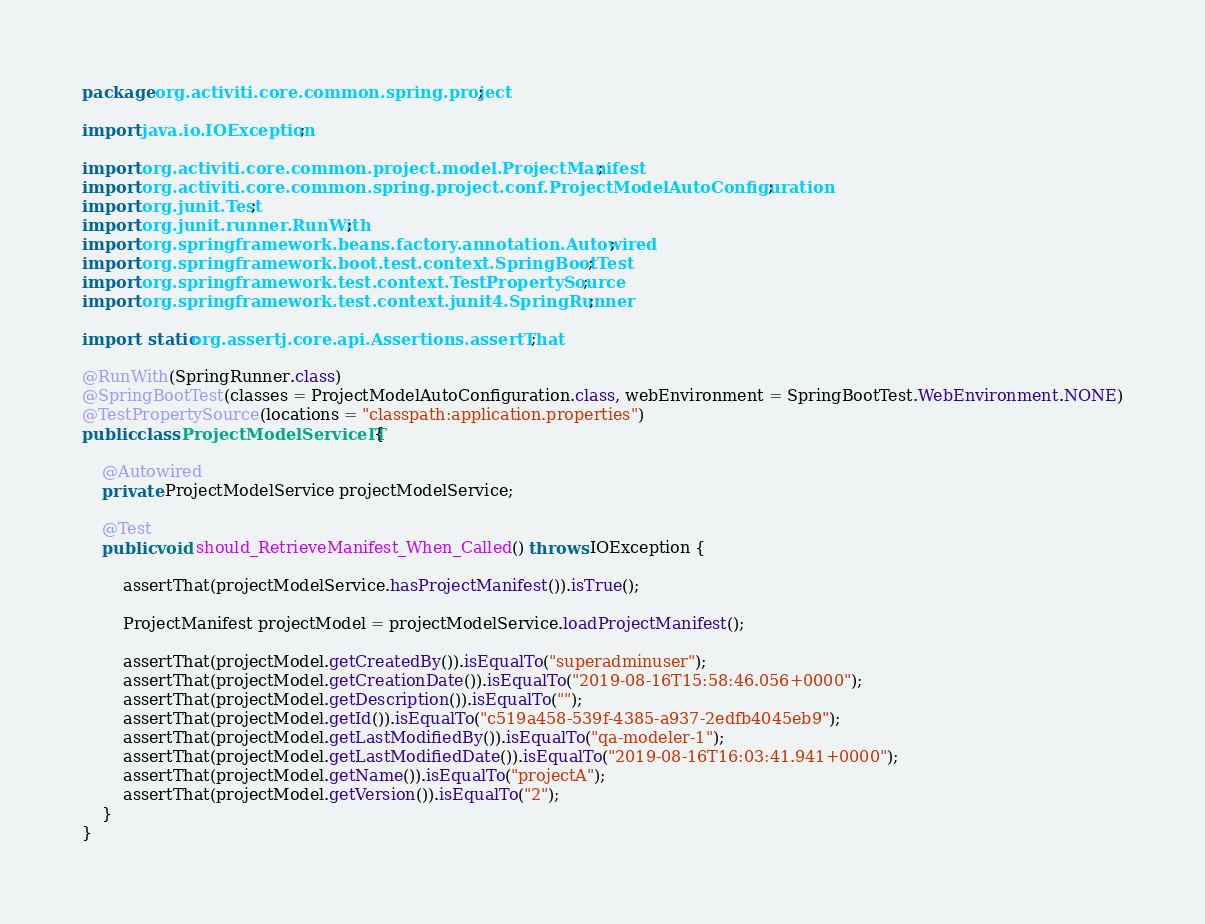<code> <loc_0><loc_0><loc_500><loc_500><_Java_>package org.activiti.core.common.spring.project;

import java.io.IOException;

import org.activiti.core.common.project.model.ProjectManifest;
import org.activiti.core.common.spring.project.conf.ProjectModelAutoConfiguration;
import org.junit.Test;
import org.junit.runner.RunWith;
import org.springframework.beans.factory.annotation.Autowired;
import org.springframework.boot.test.context.SpringBootTest;
import org.springframework.test.context.TestPropertySource;
import org.springframework.test.context.junit4.SpringRunner;

import static org.assertj.core.api.Assertions.assertThat;

@RunWith(SpringRunner.class)
@SpringBootTest(classes = ProjectModelAutoConfiguration.class, webEnvironment = SpringBootTest.WebEnvironment.NONE)
@TestPropertySource(locations = "classpath:application.properties")
public class ProjectModelServiceIT {

    @Autowired
    private ProjectModelService projectModelService;

    @Test
    public void should_RetrieveManifest_When_Called() throws IOException {

        assertThat(projectModelService.hasProjectManifest()).isTrue();

        ProjectManifest projectModel = projectModelService.loadProjectManifest();

        assertThat(projectModel.getCreatedBy()).isEqualTo("superadminuser");
        assertThat(projectModel.getCreationDate()).isEqualTo("2019-08-16T15:58:46.056+0000");
        assertThat(projectModel.getDescription()).isEqualTo("");
        assertThat(projectModel.getId()).isEqualTo("c519a458-539f-4385-a937-2edfb4045eb9");
        assertThat(projectModel.getLastModifiedBy()).isEqualTo("qa-modeler-1");
        assertThat(projectModel.getLastModifiedDate()).isEqualTo("2019-08-16T16:03:41.941+0000");
        assertThat(projectModel.getName()).isEqualTo("projectA");
        assertThat(projectModel.getVersion()).isEqualTo("2");
    }
}</code> 